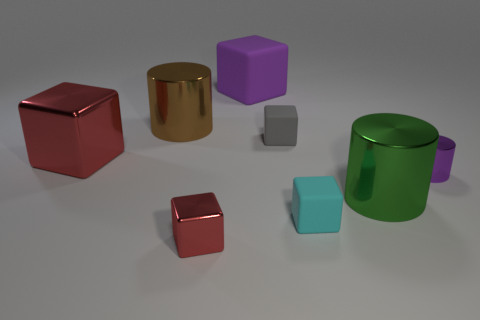Is the large rubber cube the same color as the tiny cylinder?
Ensure brevity in your answer.  Yes. How many blocks are both behind the cyan rubber thing and in front of the tiny gray thing?
Ensure brevity in your answer.  1. What shape is the small red object that is the same material as the brown cylinder?
Your response must be concise. Cube. There is a metal cylinder left of the cyan thing; is its size the same as the cyan block that is to the left of the big green cylinder?
Your response must be concise. No. What is the color of the metal cylinder that is behind the tiny cylinder?
Keep it short and to the point. Brown. There is a purple cube on the left side of the small shiny object that is right of the large purple matte cube; what is its material?
Keep it short and to the point. Rubber. The big red metallic thing has what shape?
Your answer should be compact. Cube. What is the material of the gray thing that is the same shape as the small red metallic thing?
Offer a terse response. Rubber. How many brown metallic spheres have the same size as the gray block?
Your response must be concise. 0. Is there a big cube that is in front of the large metallic cylinder on the left side of the large purple block?
Give a very brief answer. Yes. 